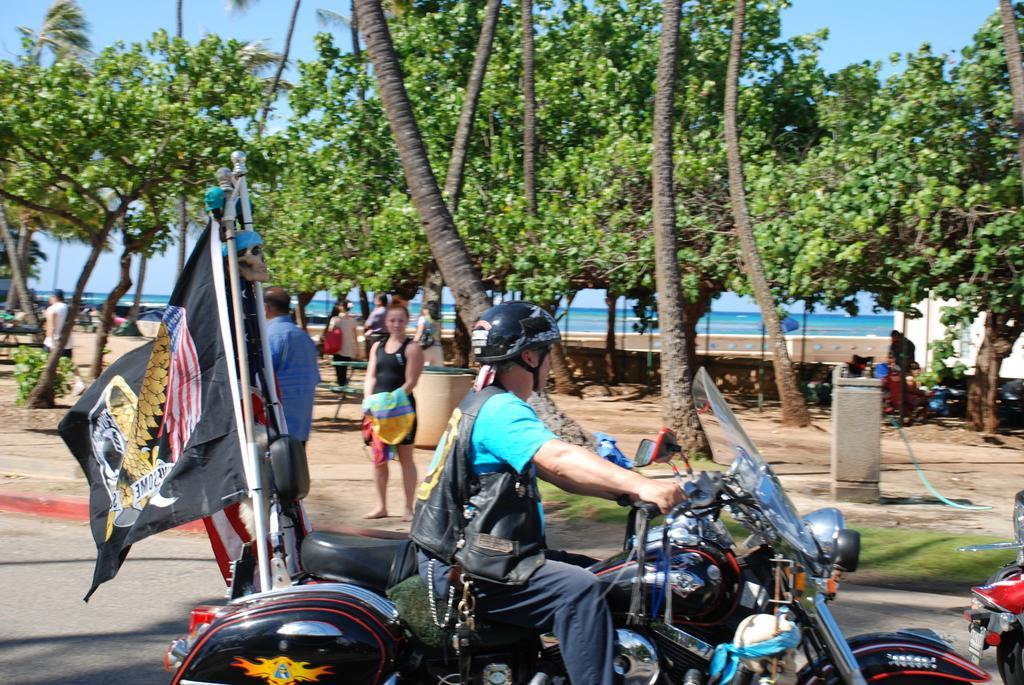Could you give a brief overview of what you see in this image? On the background of the picture we can see a blue sky and its seems like a sunny day. These are the trees. Here we can see few persons standing and sitting. here we can see one person wearing a helmet and riding a bike. this is a flag. This is a road. 